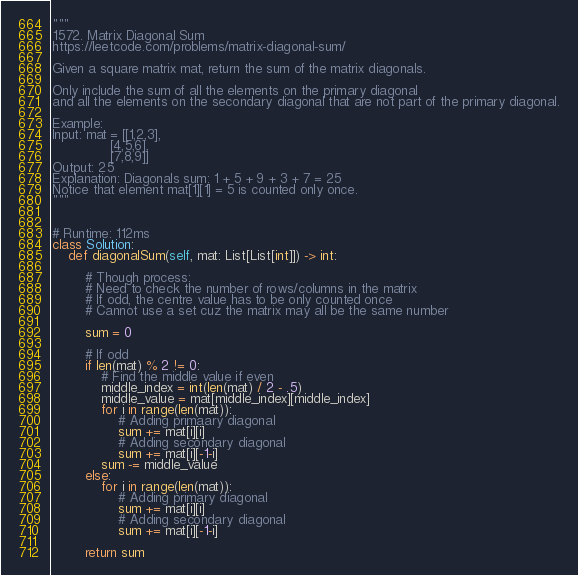<code> <loc_0><loc_0><loc_500><loc_500><_Python_>"""
1572. Matrix Diagonal Sum
https://leetcode.com/problems/matrix-diagonal-sum/

Given a square matrix mat, return the sum of the matrix diagonals.

Only include the sum of all the elements on the primary diagonal
and all the elements on the secondary diagonal that are not part of the primary diagonal.

Example:
Input: mat = [[1,2,3],
              [4,5,6],
              [7,8,9]]
Output: 25
Explanation: Diagonals sum: 1 + 5 + 9 + 3 + 7 = 25
Notice that element mat[1][1] = 5 is counted only once.
"""


# Runtime: 112ms
class Solution:
    def diagonalSum(self, mat: List[List[int]]) -> int:

        # Though process:
        # Need to check the number of rows/columns in the matrix
        # If odd, the centre value has to be only counted once
        # Cannot use a set cuz the matrix may all be the same number

        sum = 0

        # If odd
        if len(mat) % 2 != 0:
            # Find the middle value if even
            middle_index = int(len(mat) / 2 - .5)
            middle_value = mat[middle_index][middle_index]
            for i in range(len(mat)):
                # Adding primaary diagonal
                sum += mat[i][i]
                # Adding secondary diagonal
                sum += mat[i][-1-i]
            sum -= middle_value
        else:
            for i in range(len(mat)):
                # Adding primary diagonal
                sum += mat[i][i]
                # Adding secondary diagonal
                sum += mat[i][-1-i]

        return sum
</code> 